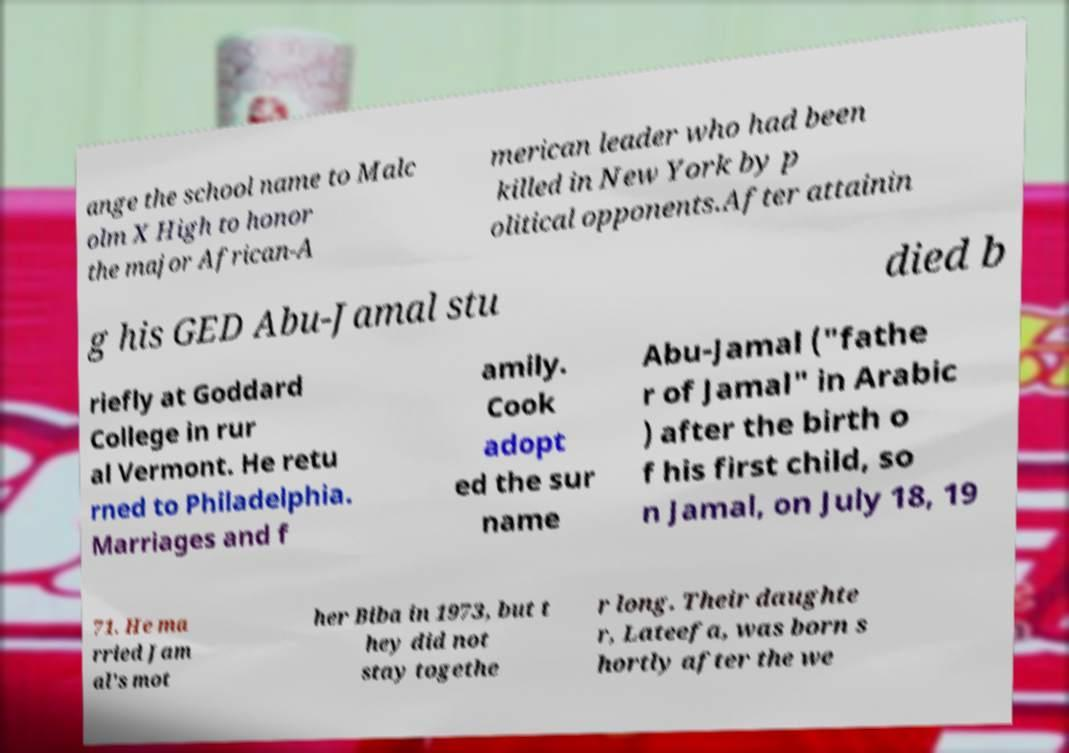Can you read and provide the text displayed in the image?This photo seems to have some interesting text. Can you extract and type it out for me? ange the school name to Malc olm X High to honor the major African-A merican leader who had been killed in New York by p olitical opponents.After attainin g his GED Abu-Jamal stu died b riefly at Goddard College in rur al Vermont. He retu rned to Philadelphia. Marriages and f amily. Cook adopt ed the sur name Abu-Jamal ("fathe r of Jamal" in Arabic ) after the birth o f his first child, so n Jamal, on July 18, 19 71. He ma rried Jam al's mot her Biba in 1973, but t hey did not stay togethe r long. Their daughte r, Lateefa, was born s hortly after the we 